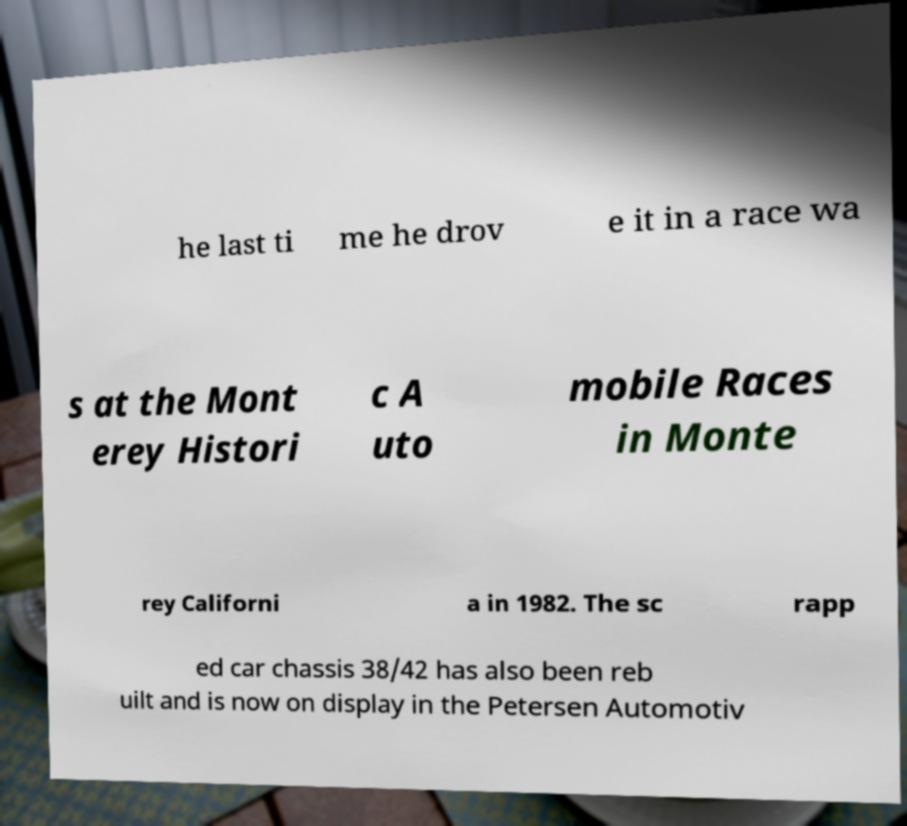Could you assist in decoding the text presented in this image and type it out clearly? he last ti me he drov e it in a race wa s at the Mont erey Histori c A uto mobile Races in Monte rey Californi a in 1982. The sc rapp ed car chassis 38/42 has also been reb uilt and is now on display in the Petersen Automotiv 